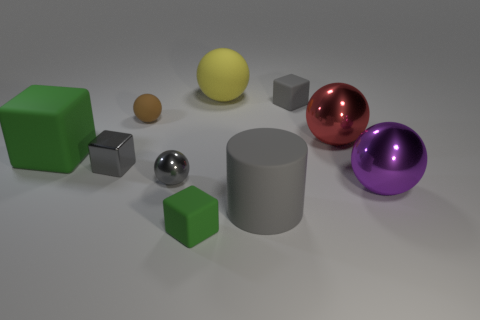Are there any other things that have the same shape as the large gray object?
Your answer should be very brief. No. Do the large rubber cylinder and the shiny cube have the same color?
Ensure brevity in your answer.  Yes. Is the material of the brown object the same as the gray ball?
Your answer should be very brief. No. What shape is the small matte thing that is to the right of the tiny matte thing that is in front of the large purple sphere?
Your response must be concise. Cube. There is a large metal object that is behind the purple thing; how many blocks are to the left of it?
Offer a terse response. 4. There is a big object that is both on the right side of the big gray cylinder and in front of the small metallic sphere; what is its material?
Your answer should be very brief. Metal. The yellow thing that is the same size as the red object is what shape?
Provide a succinct answer. Sphere. There is a big rubber object that is in front of the gray cube that is on the left side of the gray thing that is behind the big red sphere; what is its color?
Provide a short and direct response. Gray. How many objects are either big balls that are in front of the brown ball or yellow metal blocks?
Provide a succinct answer. 2. There is a purple ball that is the same size as the gray cylinder; what material is it?
Provide a short and direct response. Metal. 